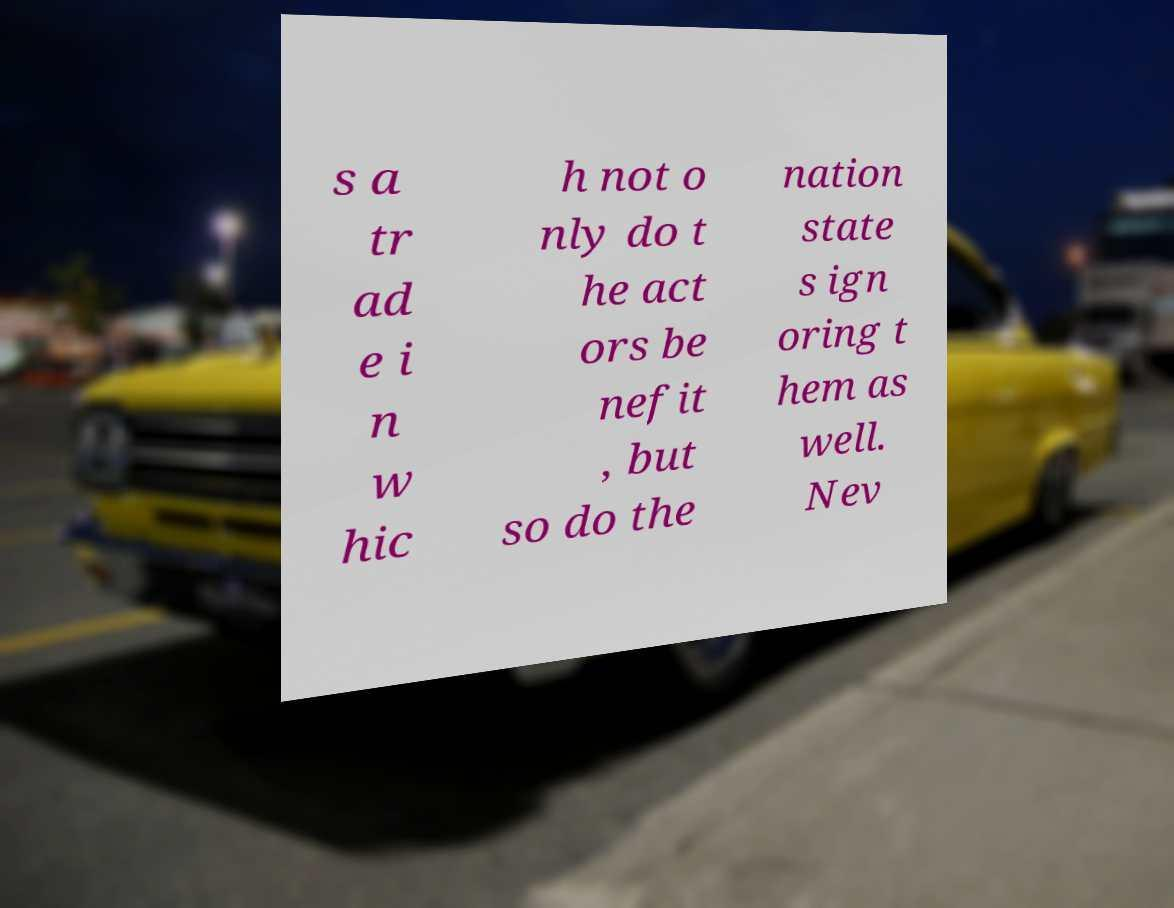Can you read and provide the text displayed in the image?This photo seems to have some interesting text. Can you extract and type it out for me? s a tr ad e i n w hic h not o nly do t he act ors be nefit , but so do the nation state s ign oring t hem as well. Nev 